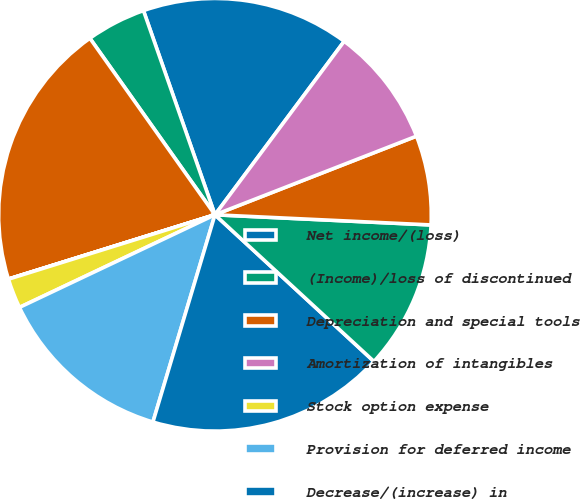<chart> <loc_0><loc_0><loc_500><loc_500><pie_chart><fcel>Net income/(loss)<fcel>(Income)/loss of discontinued<fcel>Depreciation and special tools<fcel>Amortization of intangibles<fcel>Stock option expense<fcel>Provision for deferred income<fcel>Decrease/(increase) in<fcel>Increase/(decrease) in<fcel>Net sales/(purchases) of<fcel>Other<nl><fcel>15.55%<fcel>4.45%<fcel>19.99%<fcel>0.01%<fcel>2.23%<fcel>13.33%<fcel>17.77%<fcel>11.11%<fcel>6.67%<fcel>8.89%<nl></chart> 